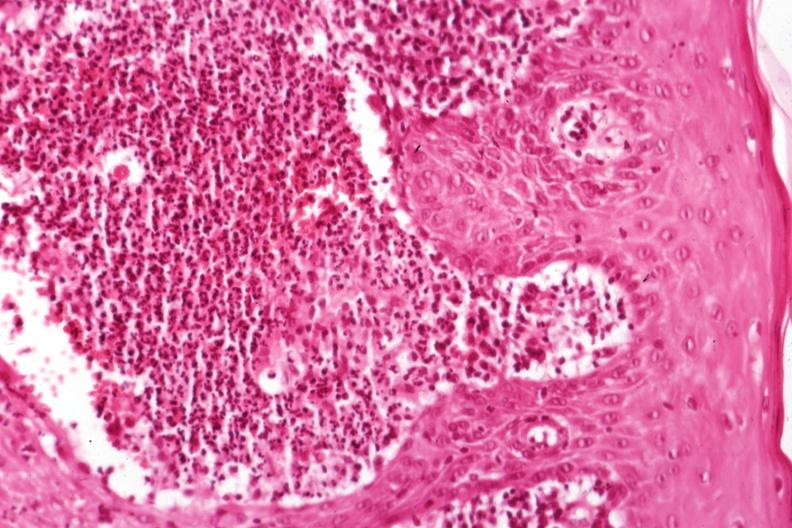s sporotrichosis present?
Answer the question using a single word or phrase. Yes 